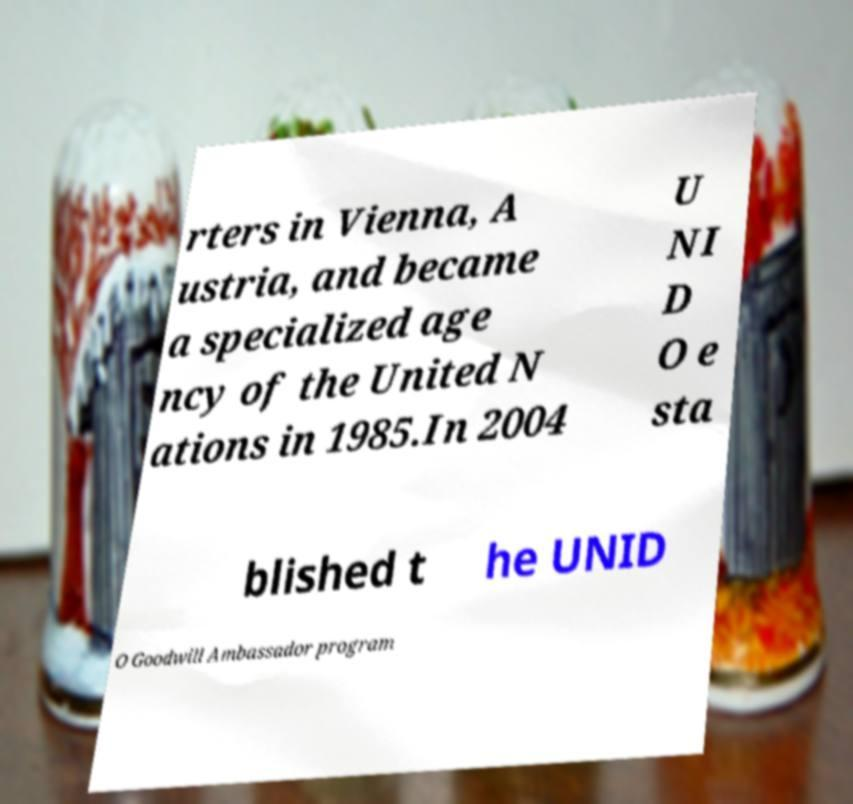Can you accurately transcribe the text from the provided image for me? rters in Vienna, A ustria, and became a specialized age ncy of the United N ations in 1985.In 2004 U NI D O e sta blished t he UNID O Goodwill Ambassador program 